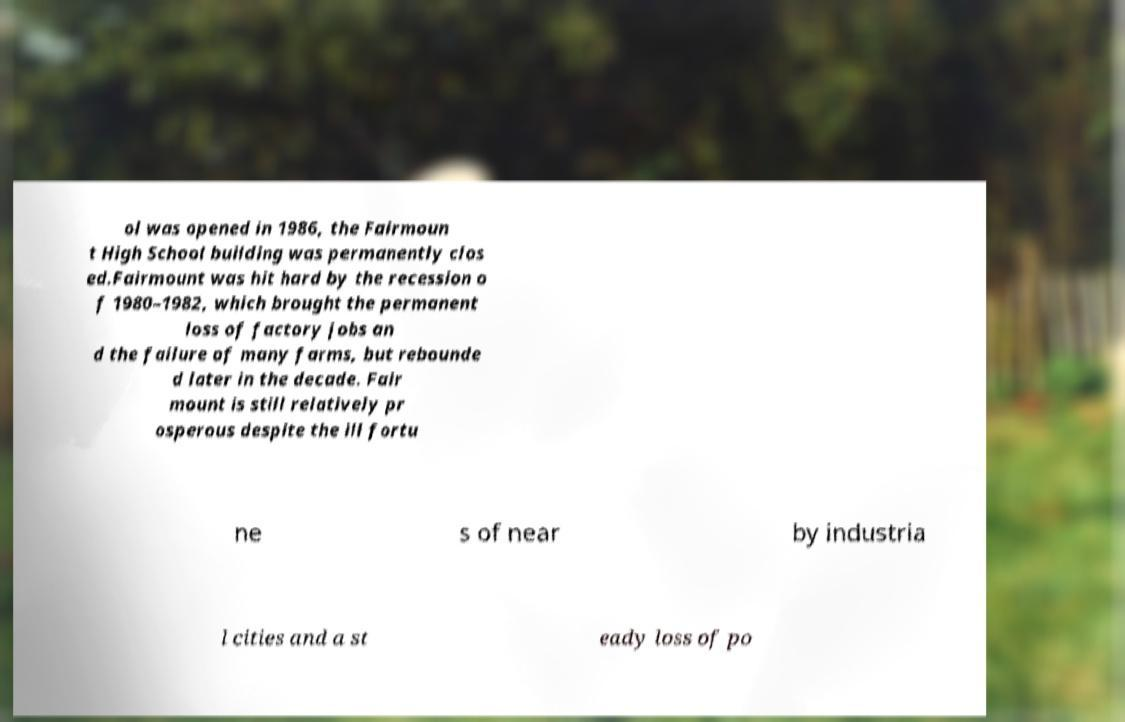Please identify and transcribe the text found in this image. ol was opened in 1986, the Fairmoun t High School building was permanently clos ed.Fairmount was hit hard by the recession o f 1980–1982, which brought the permanent loss of factory jobs an d the failure of many farms, but rebounde d later in the decade. Fair mount is still relatively pr osperous despite the ill fortu ne s of near by industria l cities and a st eady loss of po 